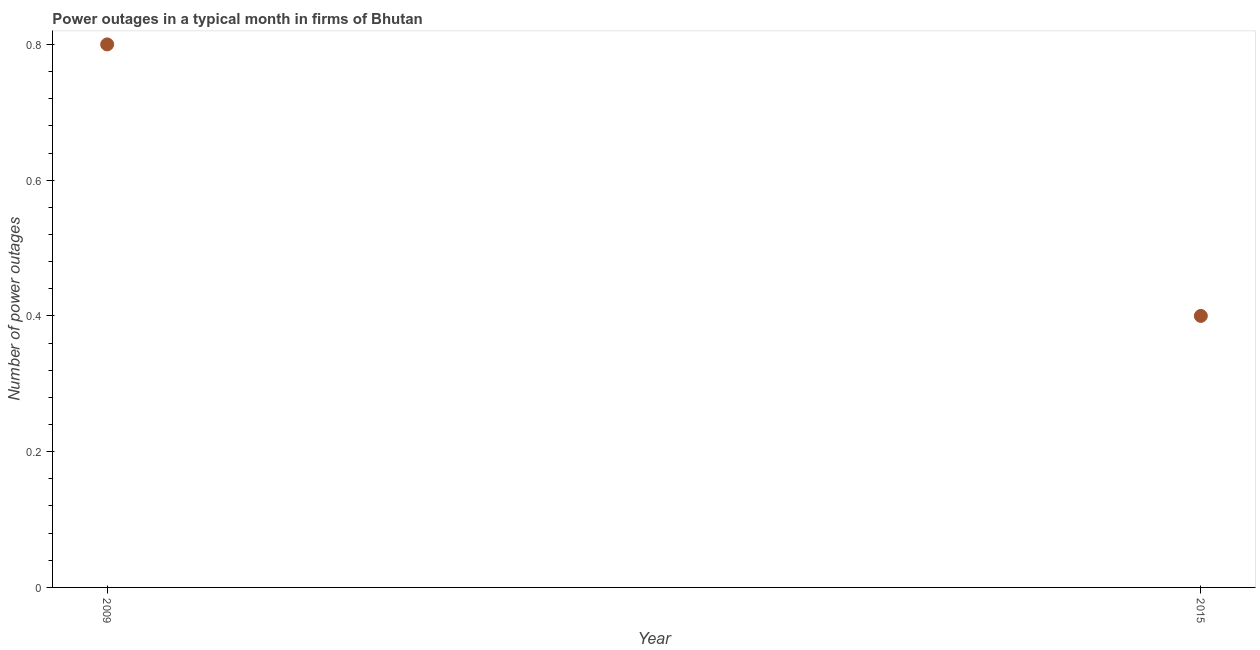What is the number of power outages in 2015?
Ensure brevity in your answer.  0.4. Across all years, what is the maximum number of power outages?
Offer a terse response. 0.8. In which year was the number of power outages maximum?
Your response must be concise. 2009. In which year was the number of power outages minimum?
Ensure brevity in your answer.  2015. What is the sum of the number of power outages?
Your answer should be very brief. 1.2. What is the average number of power outages per year?
Provide a short and direct response. 0.6. What is the median number of power outages?
Give a very brief answer. 0.6. What is the ratio of the number of power outages in 2009 to that in 2015?
Make the answer very short. 2. Does the number of power outages monotonically increase over the years?
Offer a terse response. No. How many years are there in the graph?
Your answer should be very brief. 2. Are the values on the major ticks of Y-axis written in scientific E-notation?
Provide a short and direct response. No. Does the graph contain any zero values?
Offer a terse response. No. What is the title of the graph?
Make the answer very short. Power outages in a typical month in firms of Bhutan. What is the label or title of the X-axis?
Provide a succinct answer. Year. What is the label or title of the Y-axis?
Ensure brevity in your answer.  Number of power outages. What is the Number of power outages in 2009?
Offer a terse response. 0.8. What is the Number of power outages in 2015?
Your answer should be compact. 0.4. 